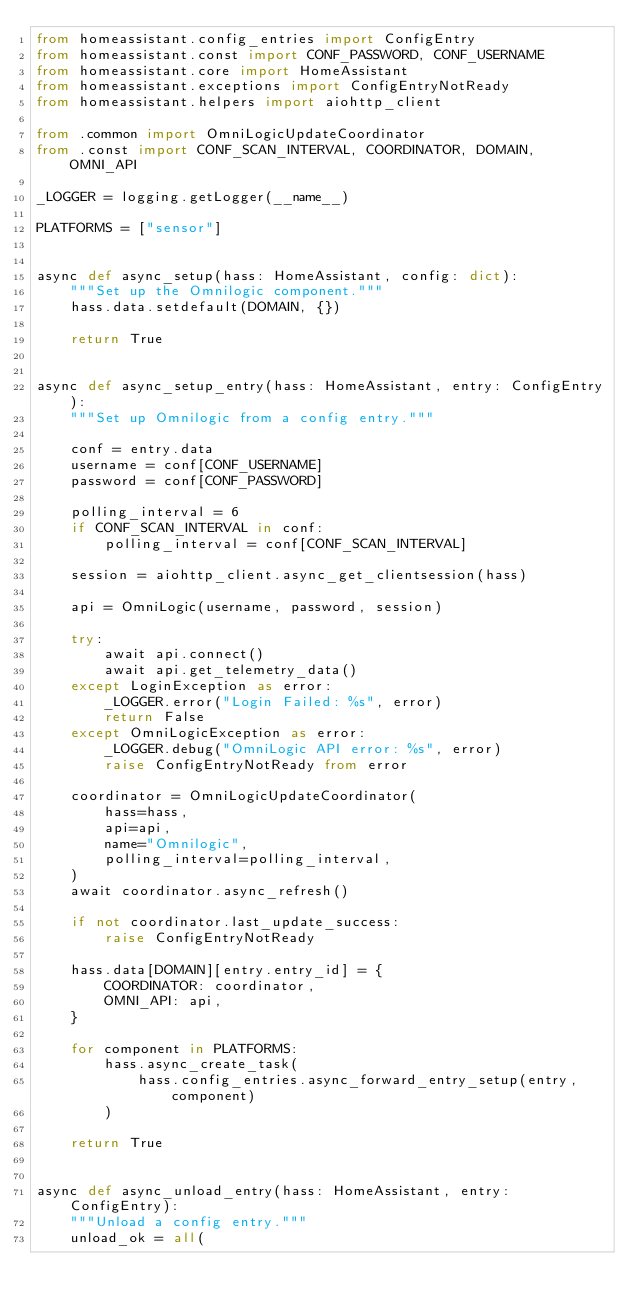<code> <loc_0><loc_0><loc_500><loc_500><_Python_>from homeassistant.config_entries import ConfigEntry
from homeassistant.const import CONF_PASSWORD, CONF_USERNAME
from homeassistant.core import HomeAssistant
from homeassistant.exceptions import ConfigEntryNotReady
from homeassistant.helpers import aiohttp_client

from .common import OmniLogicUpdateCoordinator
from .const import CONF_SCAN_INTERVAL, COORDINATOR, DOMAIN, OMNI_API

_LOGGER = logging.getLogger(__name__)

PLATFORMS = ["sensor"]


async def async_setup(hass: HomeAssistant, config: dict):
    """Set up the Omnilogic component."""
    hass.data.setdefault(DOMAIN, {})

    return True


async def async_setup_entry(hass: HomeAssistant, entry: ConfigEntry):
    """Set up Omnilogic from a config entry."""

    conf = entry.data
    username = conf[CONF_USERNAME]
    password = conf[CONF_PASSWORD]

    polling_interval = 6
    if CONF_SCAN_INTERVAL in conf:
        polling_interval = conf[CONF_SCAN_INTERVAL]

    session = aiohttp_client.async_get_clientsession(hass)

    api = OmniLogic(username, password, session)

    try:
        await api.connect()
        await api.get_telemetry_data()
    except LoginException as error:
        _LOGGER.error("Login Failed: %s", error)
        return False
    except OmniLogicException as error:
        _LOGGER.debug("OmniLogic API error: %s", error)
        raise ConfigEntryNotReady from error

    coordinator = OmniLogicUpdateCoordinator(
        hass=hass,
        api=api,
        name="Omnilogic",
        polling_interval=polling_interval,
    )
    await coordinator.async_refresh()

    if not coordinator.last_update_success:
        raise ConfigEntryNotReady

    hass.data[DOMAIN][entry.entry_id] = {
        COORDINATOR: coordinator,
        OMNI_API: api,
    }

    for component in PLATFORMS:
        hass.async_create_task(
            hass.config_entries.async_forward_entry_setup(entry, component)
        )

    return True


async def async_unload_entry(hass: HomeAssistant, entry: ConfigEntry):
    """Unload a config entry."""
    unload_ok = all(</code> 